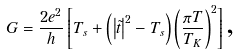<formula> <loc_0><loc_0><loc_500><loc_500>G = \frac { 2 e ^ { 2 } } { h } \left [ T _ { s } + \left ( \left | \tilde { t } \right | ^ { 2 } - T _ { s } \right ) \left ( \frac { \pi T } { T _ { K } } \right ) ^ { 2 } \right ] \text {,}</formula> 